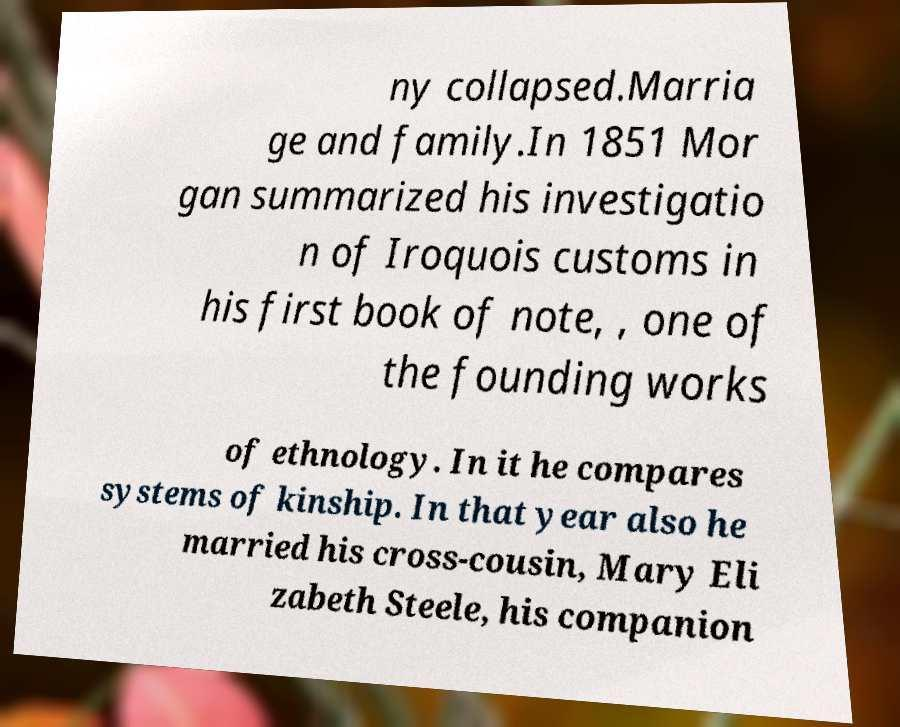Please read and relay the text visible in this image. What does it say? ny collapsed.Marria ge and family.In 1851 Mor gan summarized his investigatio n of Iroquois customs in his first book of note, , one of the founding works of ethnology. In it he compares systems of kinship. In that year also he married his cross-cousin, Mary Eli zabeth Steele, his companion 